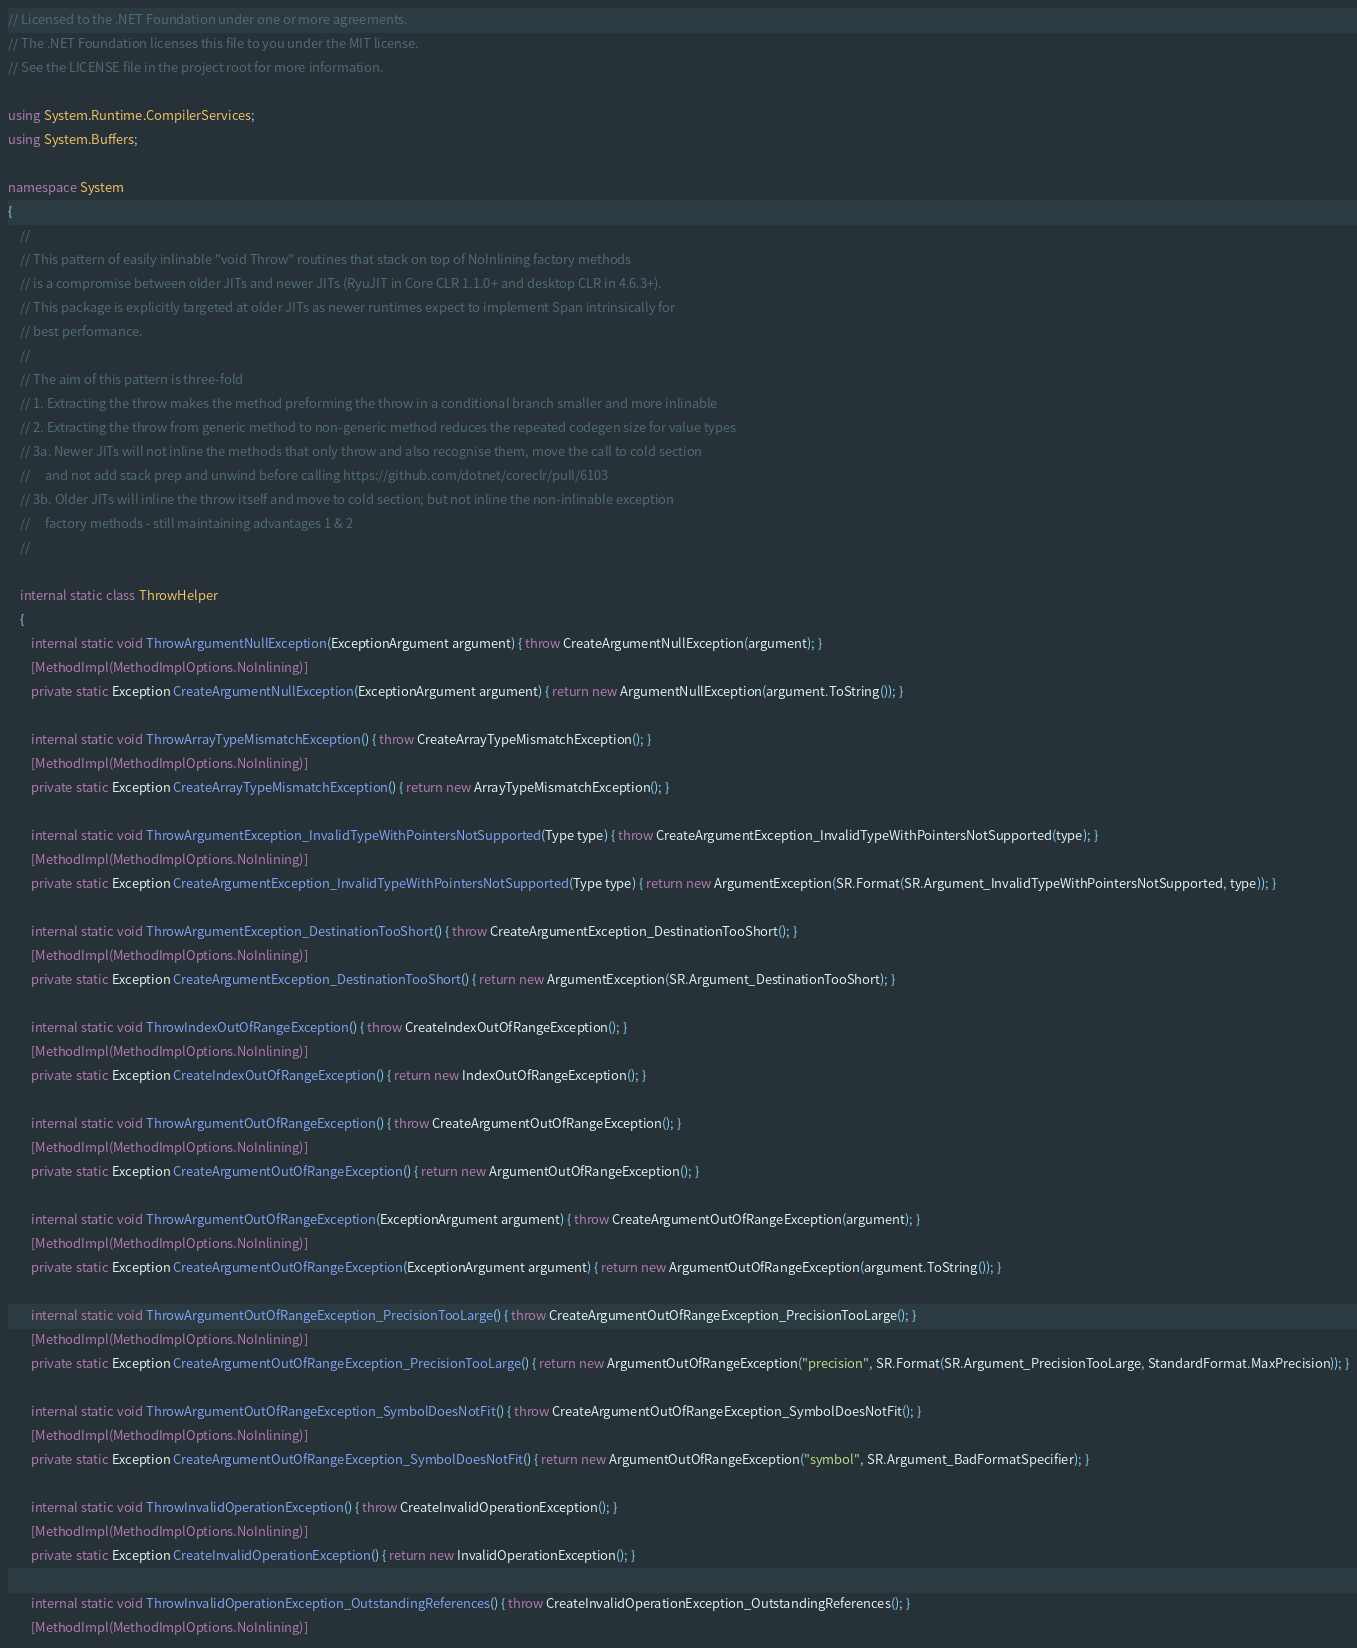<code> <loc_0><loc_0><loc_500><loc_500><_C#_>// Licensed to the .NET Foundation under one or more agreements.
// The .NET Foundation licenses this file to you under the MIT license.
// See the LICENSE file in the project root for more information.

using System.Runtime.CompilerServices;
using System.Buffers;

namespace System
{
    //
    // This pattern of easily inlinable "void Throw" routines that stack on top of NoInlining factory methods
    // is a compromise between older JITs and newer JITs (RyuJIT in Core CLR 1.1.0+ and desktop CLR in 4.6.3+).
    // This package is explicitly targeted at older JITs as newer runtimes expect to implement Span intrinsically for
    // best performance.
    //
    // The aim of this pattern is three-fold
    // 1. Extracting the throw makes the method preforming the throw in a conditional branch smaller and more inlinable
    // 2. Extracting the throw from generic method to non-generic method reduces the repeated codegen size for value types
    // 3a. Newer JITs will not inline the methods that only throw and also recognise them, move the call to cold section
    //     and not add stack prep and unwind before calling https://github.com/dotnet/coreclr/pull/6103
    // 3b. Older JITs will inline the throw itself and move to cold section; but not inline the non-inlinable exception
    //     factory methods - still maintaining advantages 1 & 2
    //

    internal static class ThrowHelper
    {
        internal static void ThrowArgumentNullException(ExceptionArgument argument) { throw CreateArgumentNullException(argument); }
        [MethodImpl(MethodImplOptions.NoInlining)]
        private static Exception CreateArgumentNullException(ExceptionArgument argument) { return new ArgumentNullException(argument.ToString()); }

        internal static void ThrowArrayTypeMismatchException() { throw CreateArrayTypeMismatchException(); }
        [MethodImpl(MethodImplOptions.NoInlining)]
        private static Exception CreateArrayTypeMismatchException() { return new ArrayTypeMismatchException(); }

        internal static void ThrowArgumentException_InvalidTypeWithPointersNotSupported(Type type) { throw CreateArgumentException_InvalidTypeWithPointersNotSupported(type); }
        [MethodImpl(MethodImplOptions.NoInlining)]
        private static Exception CreateArgumentException_InvalidTypeWithPointersNotSupported(Type type) { return new ArgumentException(SR.Format(SR.Argument_InvalidTypeWithPointersNotSupported, type)); }

        internal static void ThrowArgumentException_DestinationTooShort() { throw CreateArgumentException_DestinationTooShort(); }
        [MethodImpl(MethodImplOptions.NoInlining)]
        private static Exception CreateArgumentException_DestinationTooShort() { return new ArgumentException(SR.Argument_DestinationTooShort); }

        internal static void ThrowIndexOutOfRangeException() { throw CreateIndexOutOfRangeException(); }
        [MethodImpl(MethodImplOptions.NoInlining)]
        private static Exception CreateIndexOutOfRangeException() { return new IndexOutOfRangeException(); }

        internal static void ThrowArgumentOutOfRangeException() { throw CreateArgumentOutOfRangeException(); }
        [MethodImpl(MethodImplOptions.NoInlining)]
        private static Exception CreateArgumentOutOfRangeException() { return new ArgumentOutOfRangeException(); }

        internal static void ThrowArgumentOutOfRangeException(ExceptionArgument argument) { throw CreateArgumentOutOfRangeException(argument); }
        [MethodImpl(MethodImplOptions.NoInlining)]
        private static Exception CreateArgumentOutOfRangeException(ExceptionArgument argument) { return new ArgumentOutOfRangeException(argument.ToString()); }

        internal static void ThrowArgumentOutOfRangeException_PrecisionTooLarge() { throw CreateArgumentOutOfRangeException_PrecisionTooLarge(); }
        [MethodImpl(MethodImplOptions.NoInlining)]
        private static Exception CreateArgumentOutOfRangeException_PrecisionTooLarge() { return new ArgumentOutOfRangeException("precision", SR.Format(SR.Argument_PrecisionTooLarge, StandardFormat.MaxPrecision)); }

        internal static void ThrowArgumentOutOfRangeException_SymbolDoesNotFit() { throw CreateArgumentOutOfRangeException_SymbolDoesNotFit(); }
        [MethodImpl(MethodImplOptions.NoInlining)]
        private static Exception CreateArgumentOutOfRangeException_SymbolDoesNotFit() { return new ArgumentOutOfRangeException("symbol", SR.Argument_BadFormatSpecifier); }

        internal static void ThrowInvalidOperationException() { throw CreateInvalidOperationException(); }
        [MethodImpl(MethodImplOptions.NoInlining)]
        private static Exception CreateInvalidOperationException() { return new InvalidOperationException(); }

        internal static void ThrowInvalidOperationException_OutstandingReferences() { throw CreateInvalidOperationException_OutstandingReferences(); }
        [MethodImpl(MethodImplOptions.NoInlining)]</code> 